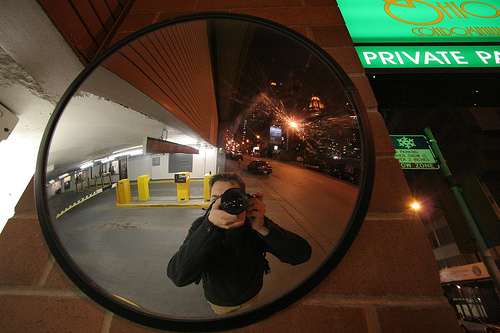<image>
Is the camera in the mirror? Yes. The camera is contained within or inside the mirror, showing a containment relationship. 